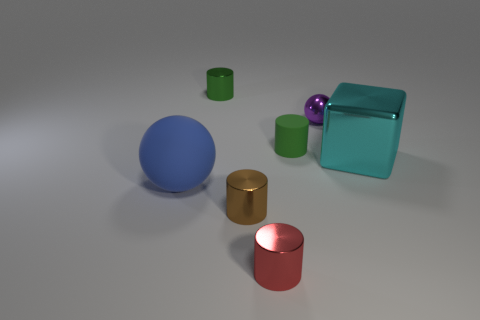What size is the green object that is to the left of the red object? The green object to the left of the red cylinder appears to be small in size, approximately half the height of the red object, creating a contrast in their dimensions that highlights the smaller stature of the green one. 